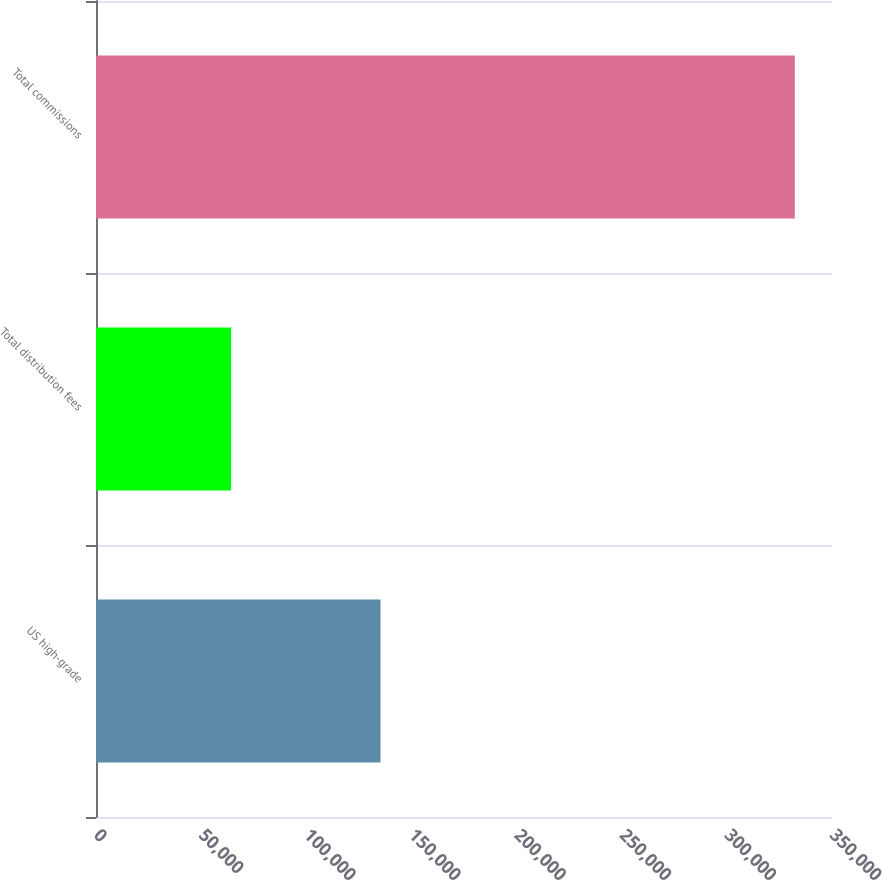<chart> <loc_0><loc_0><loc_500><loc_500><bar_chart><fcel>US high-grade<fcel>Total distribution fees<fcel>Total commissions<nl><fcel>135295<fcel>64241<fcel>332307<nl></chart> 